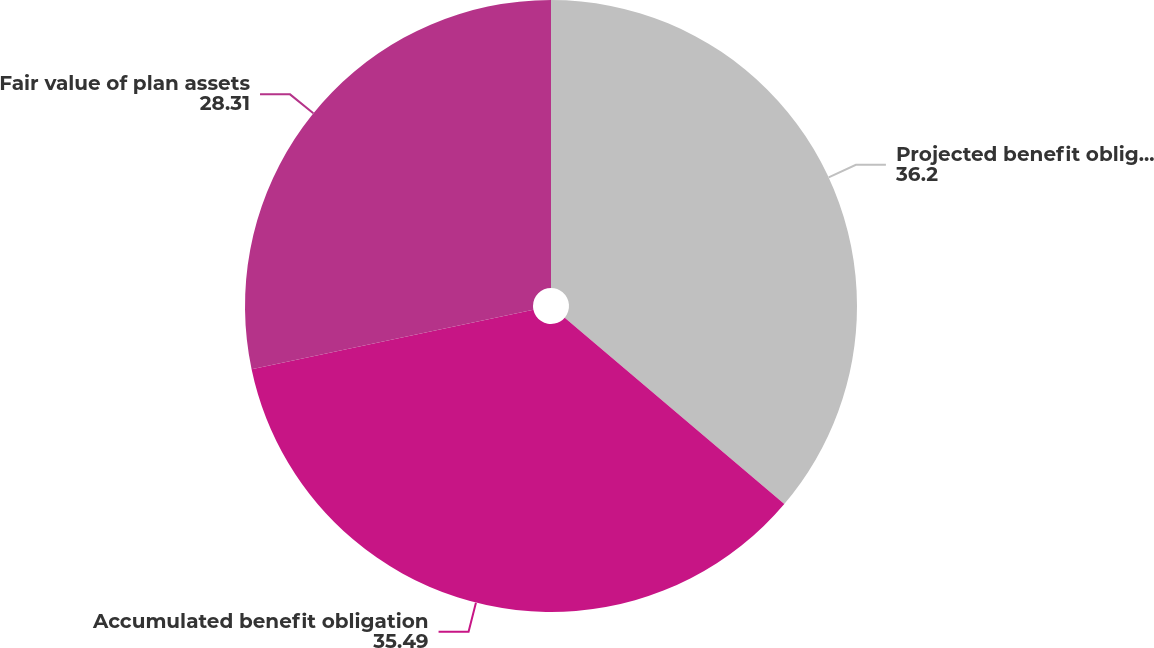Convert chart to OTSL. <chart><loc_0><loc_0><loc_500><loc_500><pie_chart><fcel>Projected benefit obligation<fcel>Accumulated benefit obligation<fcel>Fair value of plan assets<nl><fcel>36.2%<fcel>35.49%<fcel>28.31%<nl></chart> 